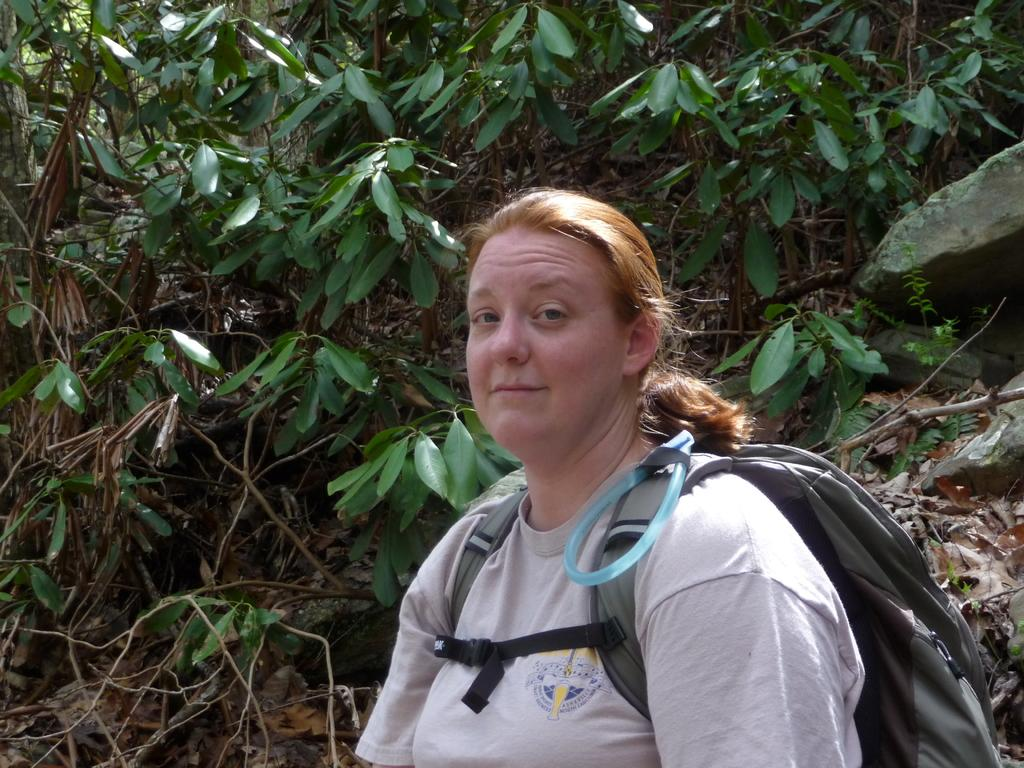Who is the main subject in the image? There is a lady in the image. What is the lady carrying in the image? The lady is carrying a backpack. What can be seen in the background of the image? There are trees in the background of the image. What type of button is sewn onto the stem of the lady's backpack in the image? There is no button or stem present on the lady's backpack in the image. 